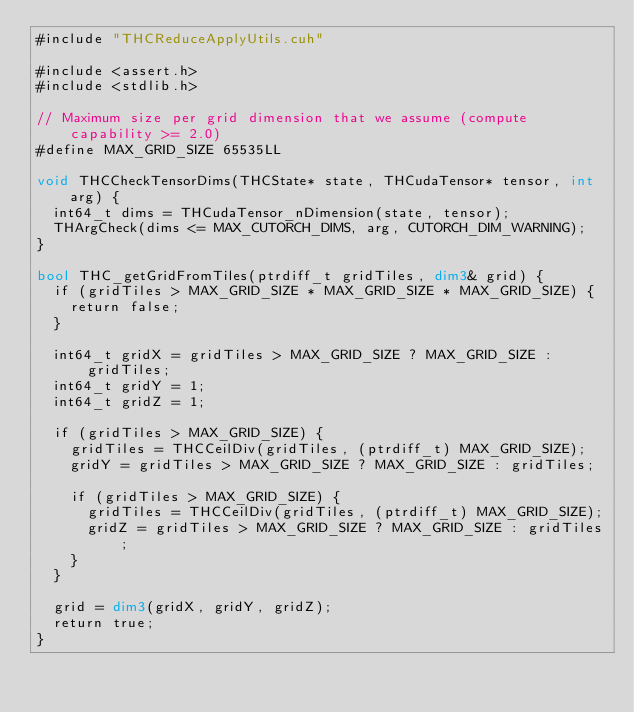Convert code to text. <code><loc_0><loc_0><loc_500><loc_500><_Cuda_>#include "THCReduceApplyUtils.cuh"

#include <assert.h>
#include <stdlib.h>

// Maximum size per grid dimension that we assume (compute capability >= 2.0)
#define MAX_GRID_SIZE 65535LL

void THCCheckTensorDims(THCState* state, THCudaTensor* tensor, int arg) {
  int64_t dims = THCudaTensor_nDimension(state, tensor);
  THArgCheck(dims <= MAX_CUTORCH_DIMS, arg, CUTORCH_DIM_WARNING);
}

bool THC_getGridFromTiles(ptrdiff_t gridTiles, dim3& grid) {
  if (gridTiles > MAX_GRID_SIZE * MAX_GRID_SIZE * MAX_GRID_SIZE) {
    return false;
  }

  int64_t gridX = gridTiles > MAX_GRID_SIZE ? MAX_GRID_SIZE : gridTiles;
  int64_t gridY = 1;
  int64_t gridZ = 1;

  if (gridTiles > MAX_GRID_SIZE) {
    gridTiles = THCCeilDiv(gridTiles, (ptrdiff_t) MAX_GRID_SIZE);
    gridY = gridTiles > MAX_GRID_SIZE ? MAX_GRID_SIZE : gridTiles;

    if (gridTiles > MAX_GRID_SIZE) {
      gridTiles = THCCeilDiv(gridTiles, (ptrdiff_t) MAX_GRID_SIZE);
      gridZ = gridTiles > MAX_GRID_SIZE ? MAX_GRID_SIZE : gridTiles;
    }
  }

  grid = dim3(gridX, gridY, gridZ);
  return true;
}
</code> 